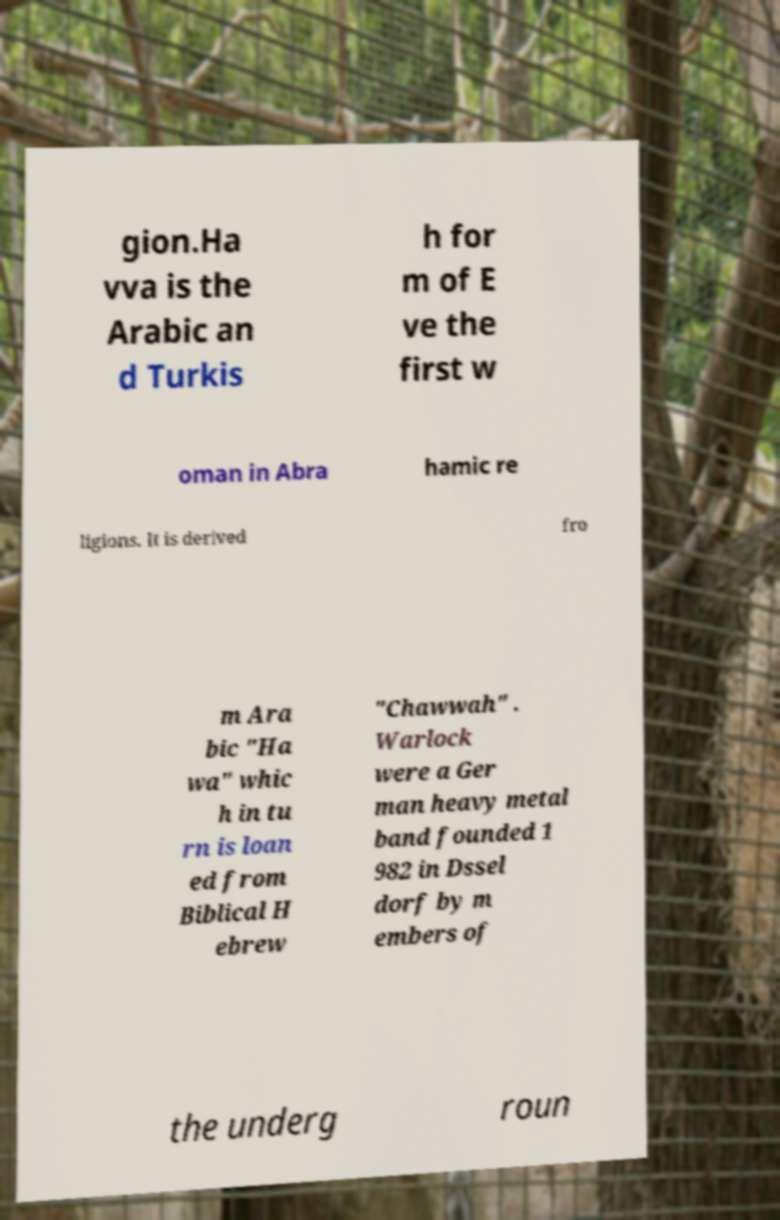Please identify and transcribe the text found in this image. gion.Ha vva is the Arabic an d Turkis h for m of E ve the first w oman in Abra hamic re ligions. It is derived fro m Ara bic "Ha wa" whic h in tu rn is loan ed from Biblical H ebrew "Chawwah" . Warlock were a Ger man heavy metal band founded 1 982 in Dssel dorf by m embers of the underg roun 